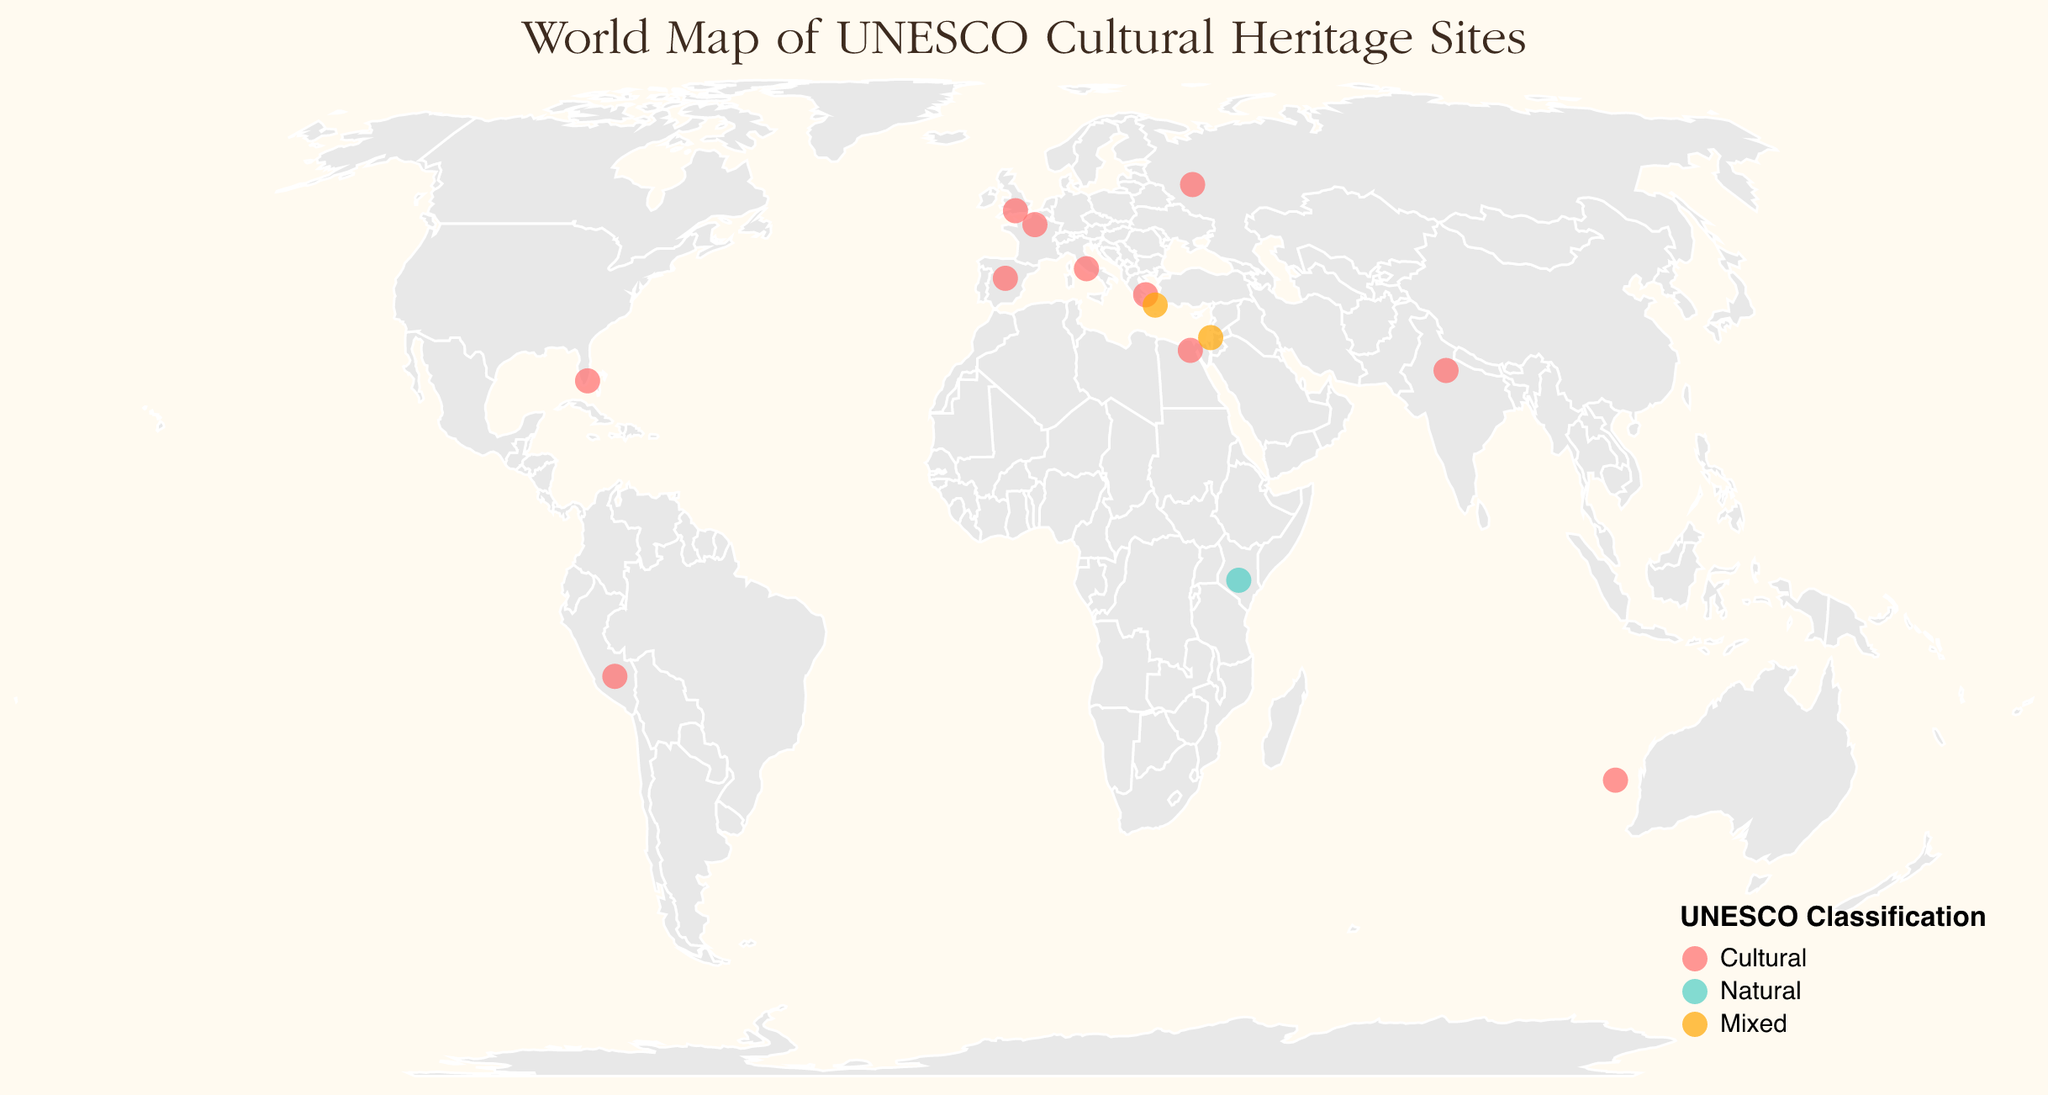How many cultural heritage sites are shown in the figure? By counting the UNESCO classification labeled as "Cultural" on the map, we see the following sites: Palace of Versailles, Historic Centre of Rome, Pyramids of Giza, El Escorial, Taj Mahal, Machu Picchu, Stonehenge, Rapa Nui National Park, Art Deco Historic District, Acropolis of Athens, and Kremlin and Red Square. This gives a total of 11 cultural heritage sites.
Answer: 11 Which site was recognized most recently? By looking at the tooltip or categorization on the map, we can compare the "Year Recognized" attribute for each site. The "Santorini Caldera" in Greece, classified as Mixed, is recognized in 2024 which is the most recent year among all the sites shown.
Answer: Santorini Caldera Which country has the highest number of UNESCO sites listed, and what are they? By examining the "Country" attribute on the map for all points, we find Greece has two sites listed: "Acropolis of Athens" and "Santorini Caldera." All other countries have only one site listed in the figure.
Answer: Greece How many sites have been recognized before 1990? By checking the "Year Recognized" attribute, the sites recognized before 1990 are Palace of Versailles (1979), Historic Centre of Rome (1980), Pyramids of Giza (1979), El Escorial (1984), Taj Mahal (1983), Machu Picchu (1983), Stonehenge (1986), Old City of Jerusalem (1981), and Acropolis of Athens (1987), which are a total of 9 sites.
Answer: 9 Which UNESCO classification has the most sites in the figure? By examining the "UNESCO_Classification" attribute, we can count the number of sites for each classification. Cultural has 11 sites, Natural has 1 site, and Mixed has 2 sites. Therefore, Cultural has the most sites.
Answer: Cultural Are there any UNESCO natural heritage sites on the list? By looking at the "UNESCO_Classification" field, we see there is one site classified as "Natural": Mount Kenya National Park in Kenya.
Answer: Yes Which site is the furthest south? By comparing the "Latitude" values of all the sites, the site with the smallest (most negative) latitude is Rapa Nui National Park, located at approximately -27.1258° latitude.
Answer: Rapa Nui National Park How many sites belong to the Mixed classification? By counting the number of times "Mixed" appears in the "UNESCO_Classification" field, we find two such sites: Old City of Jerusalem and Santorini Caldera.
Answer: 2 Which site is further west, the Taj Mahal or the Pyramids of Giza? By comparing the "Longitude" values of both sites, Taj Mahal has a longitude of 78.0422 and Pyramids of Giza have a longitude of 31.1342. Since 78.0422 is greater than 31.1342, Taj Mahal is further east. Therefore, Pyramids of Giza is further west.
Answer: Pyramids of Giza 